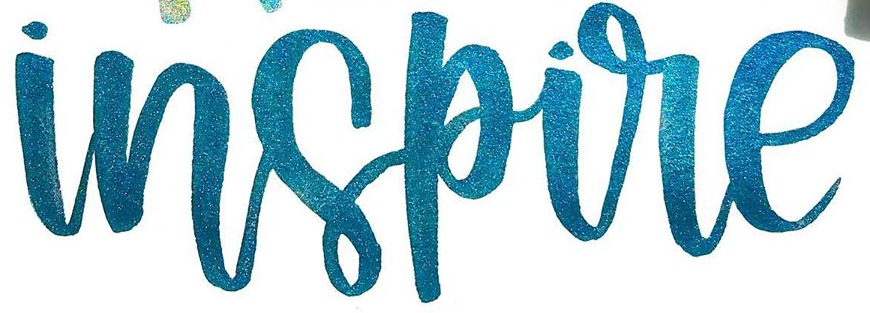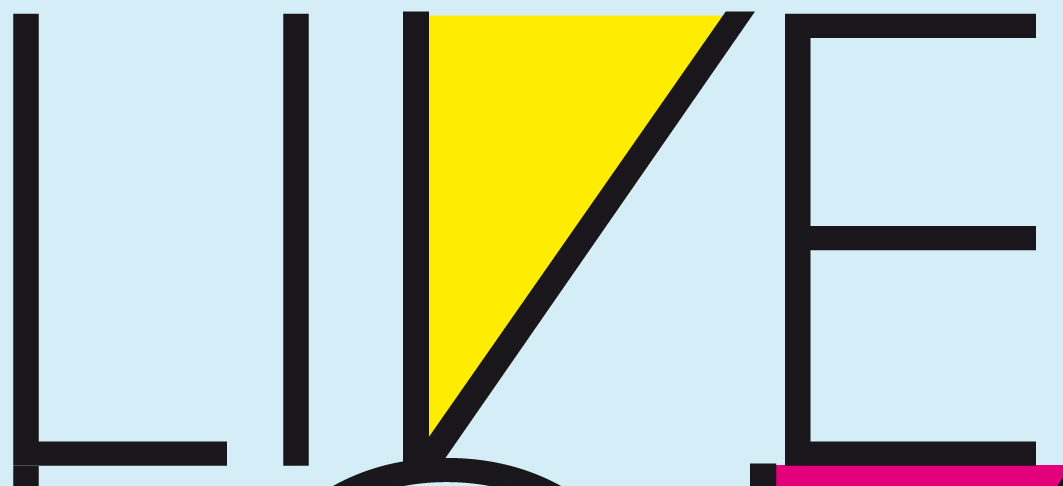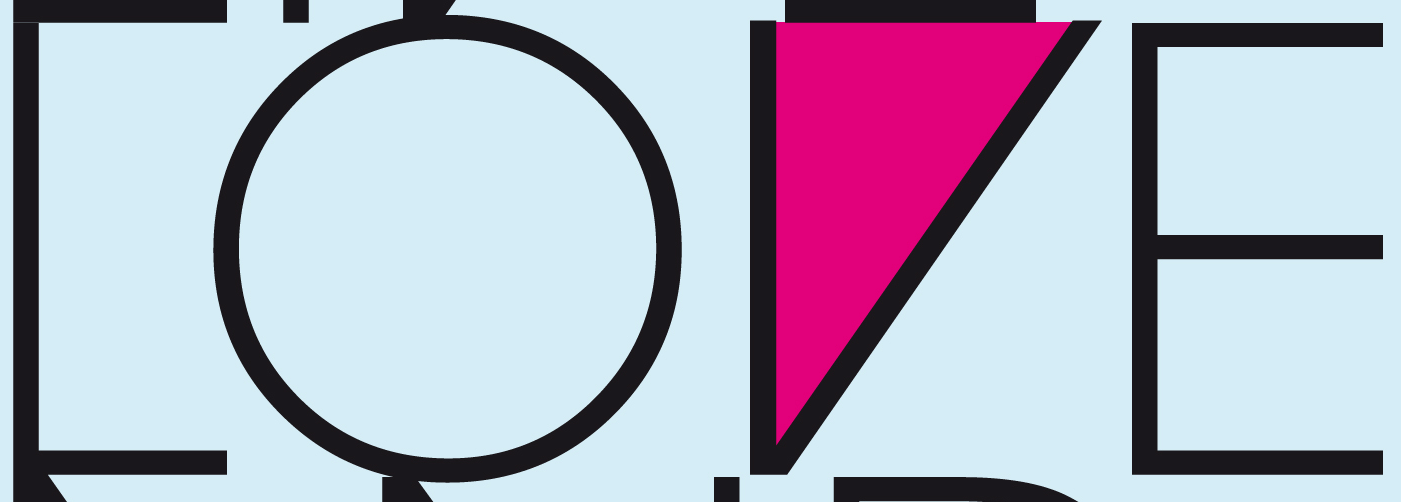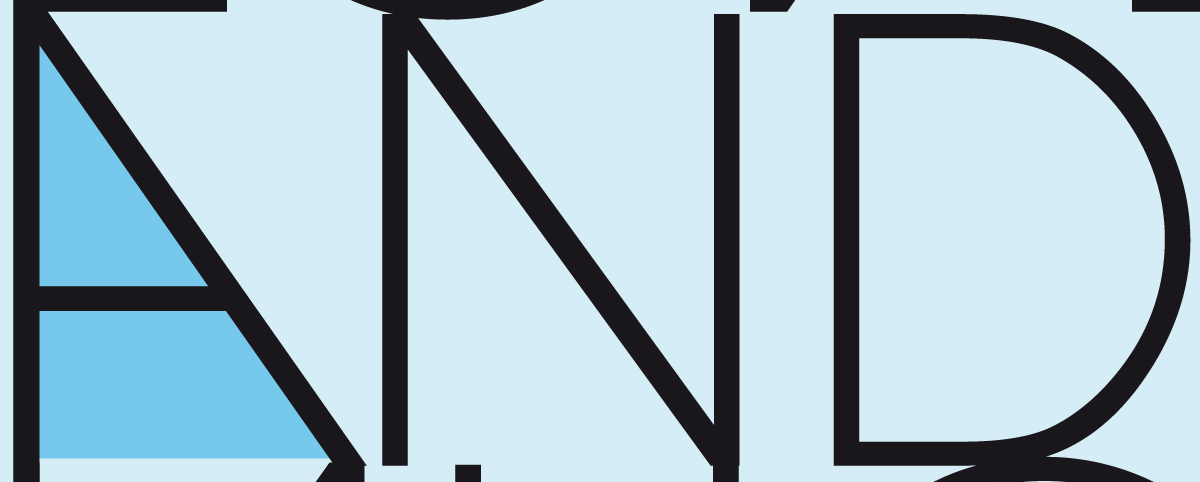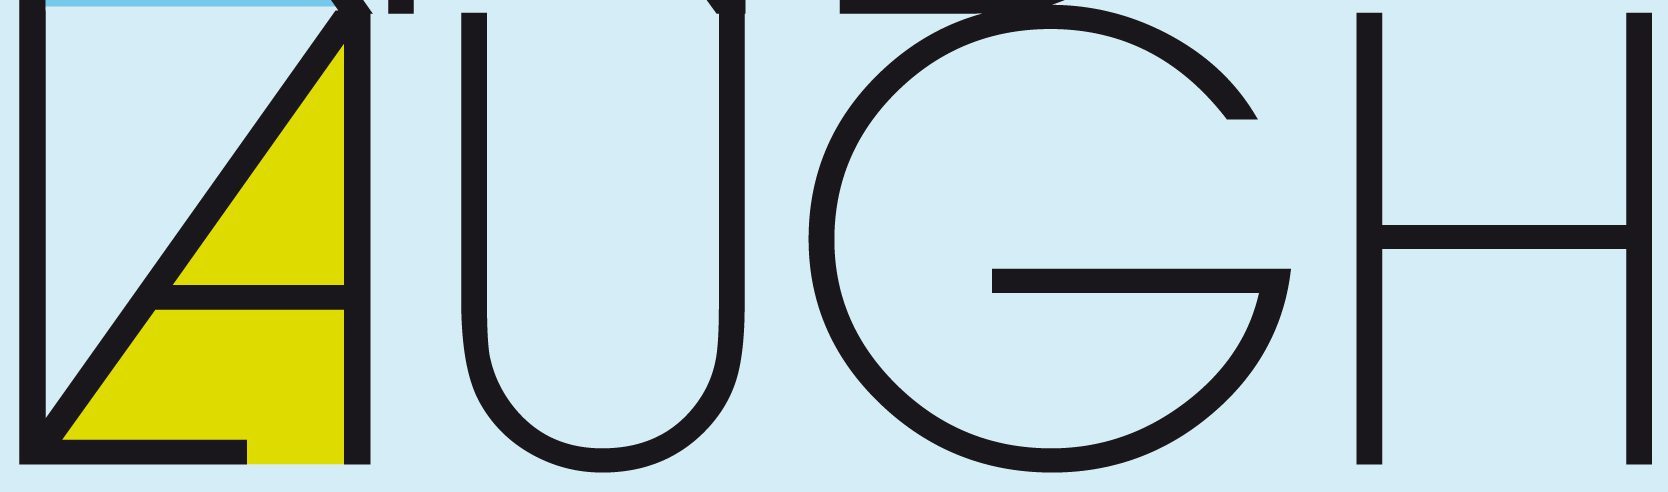What words can you see in these images in sequence, separated by a semicolon? inspire; LIVE; LOVE; AND; LAUGH 